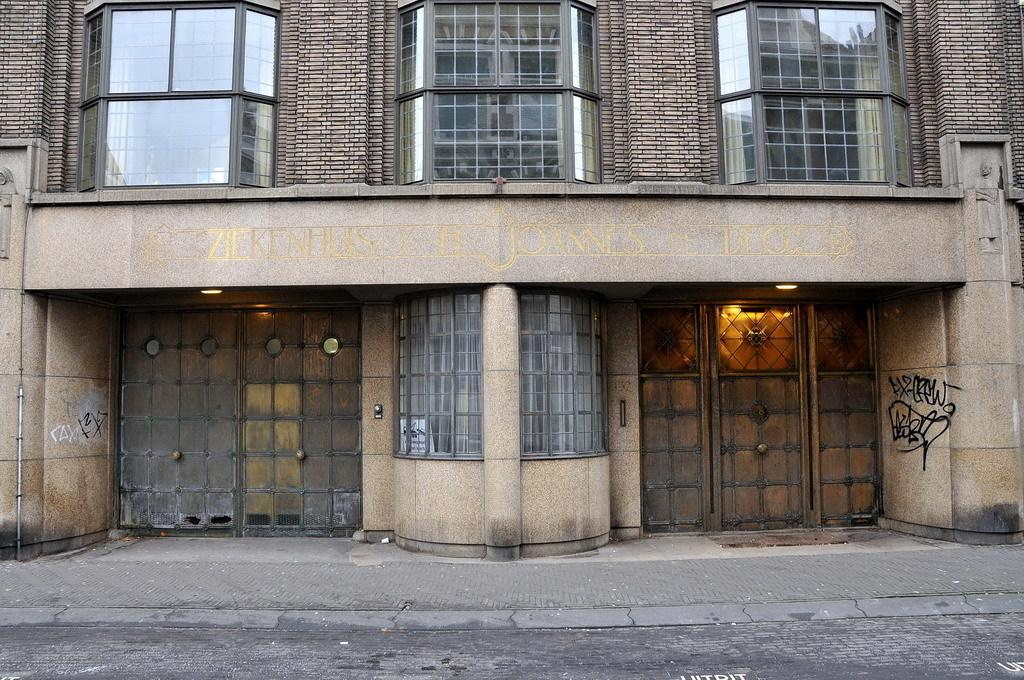What type of structure is in the picture? There is a house building in the picture. What are the main features of the house building? The house building has doors and windows with glasses on the top. What arithmetic problem can be solved using the windows on the house building? There is no arithmetic problem associated with the windows on the house building; they are simply a part of the building's design. 